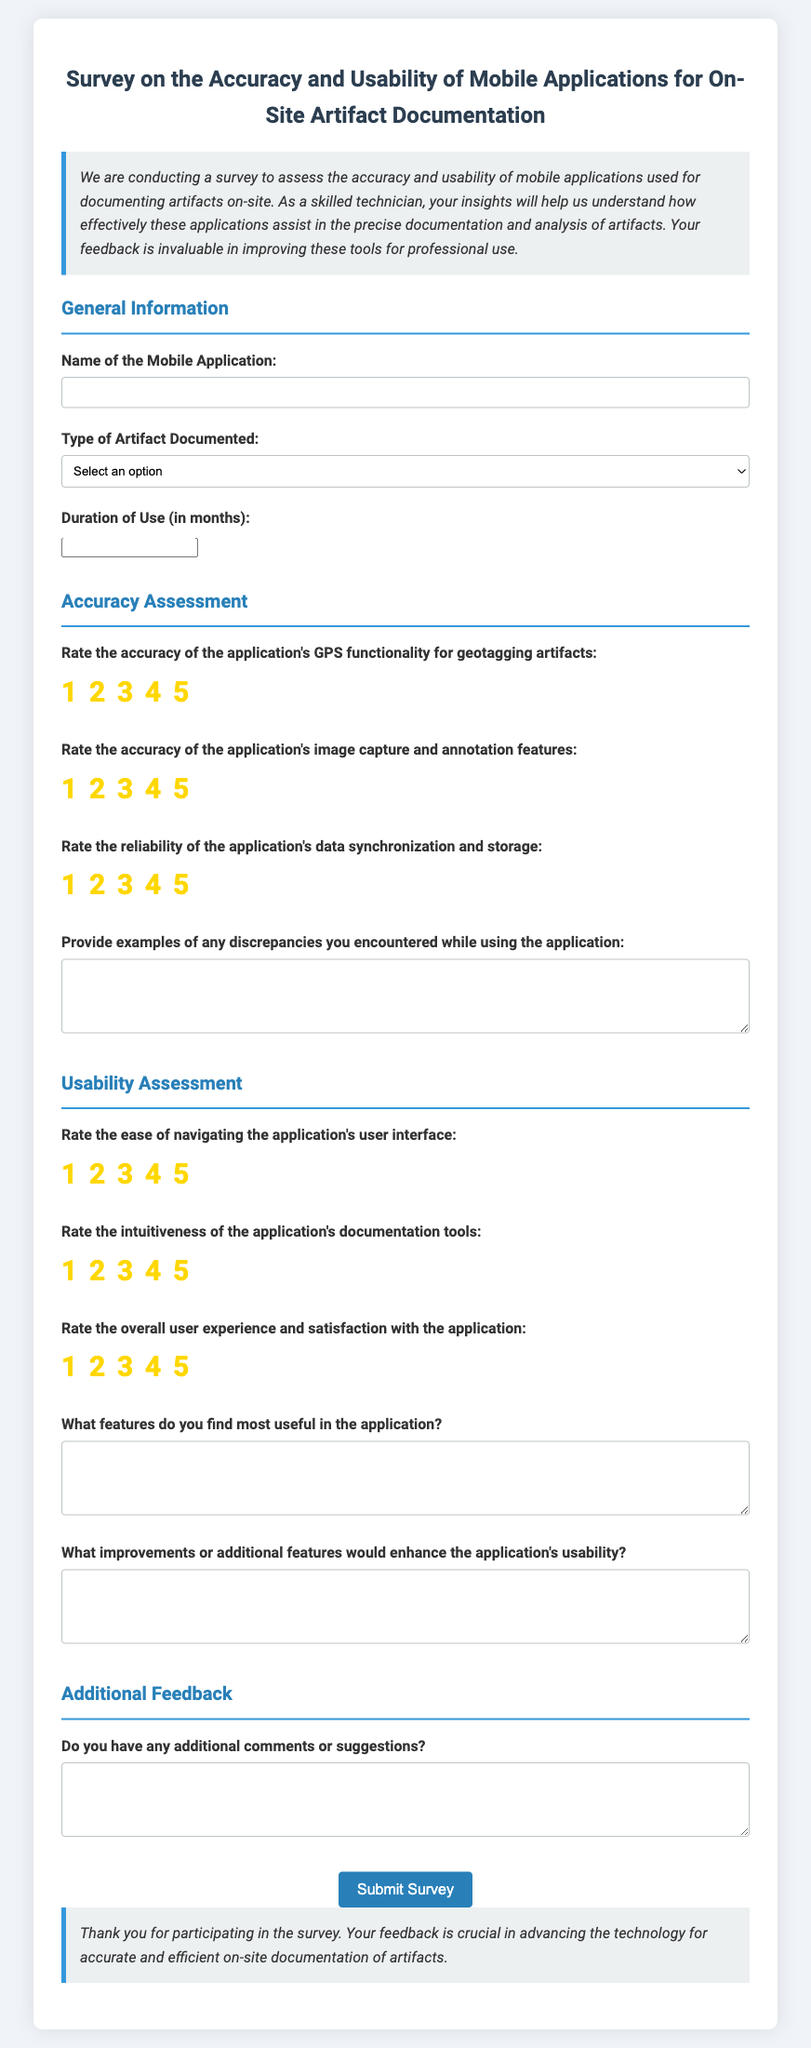What is the title of the survey? The title of the survey is prominently displayed at the top of the document.
Answer: Survey on the Accuracy and Usability of Mobile Applications for On-Site Artifact Documentation What is the required duration of use question? The question regarding duration of use asks for a specific time frame measured in months.
Answer: Duration of Use (in months) What type of artifact can be chosen in the survey? The document presents options for the type of artifact that respondents can select.
Answer: Archaeological How many criteria are assessed under Accuracy Assessment? The document outlines specific criteria for accuracy assessment related to the mobile application features.
Answer: Three What is one type of question found in the Usability Assessment section? The Usability Assessment section includes a variety of questions designed to evaluate user experience.
Answer: Rate the ease of navigating the application's user interface What should participants provide in the discrepancies field? This field asks for detailed information about any issues encountered while using the application.
Answer: Examples of any discrepancies you encountered while using the application What is the final question in the Additional Feedback section? The last question in the Additional Feedback section invites participants to share their thoughts.
Answer: Do you have any additional comments or suggestions? 